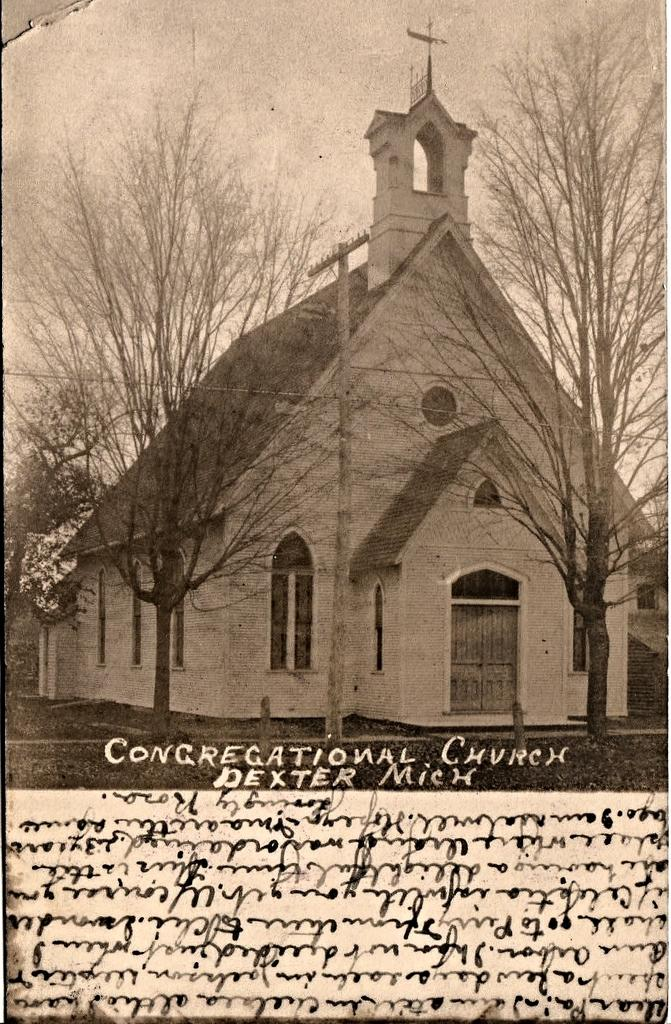<image>
Give a short and clear explanation of the subsequent image. A old black and white photo of a church in Dexter, Michigan. 